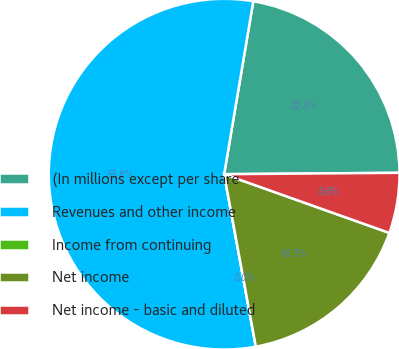<chart> <loc_0><loc_0><loc_500><loc_500><pie_chart><fcel>(In millions except per share<fcel>Revenues and other income<fcel>Income from continuing<fcel>Net income<fcel>Net income - basic and diluted<nl><fcel>22.22%<fcel>55.55%<fcel>0.0%<fcel>16.67%<fcel>5.56%<nl></chart> 